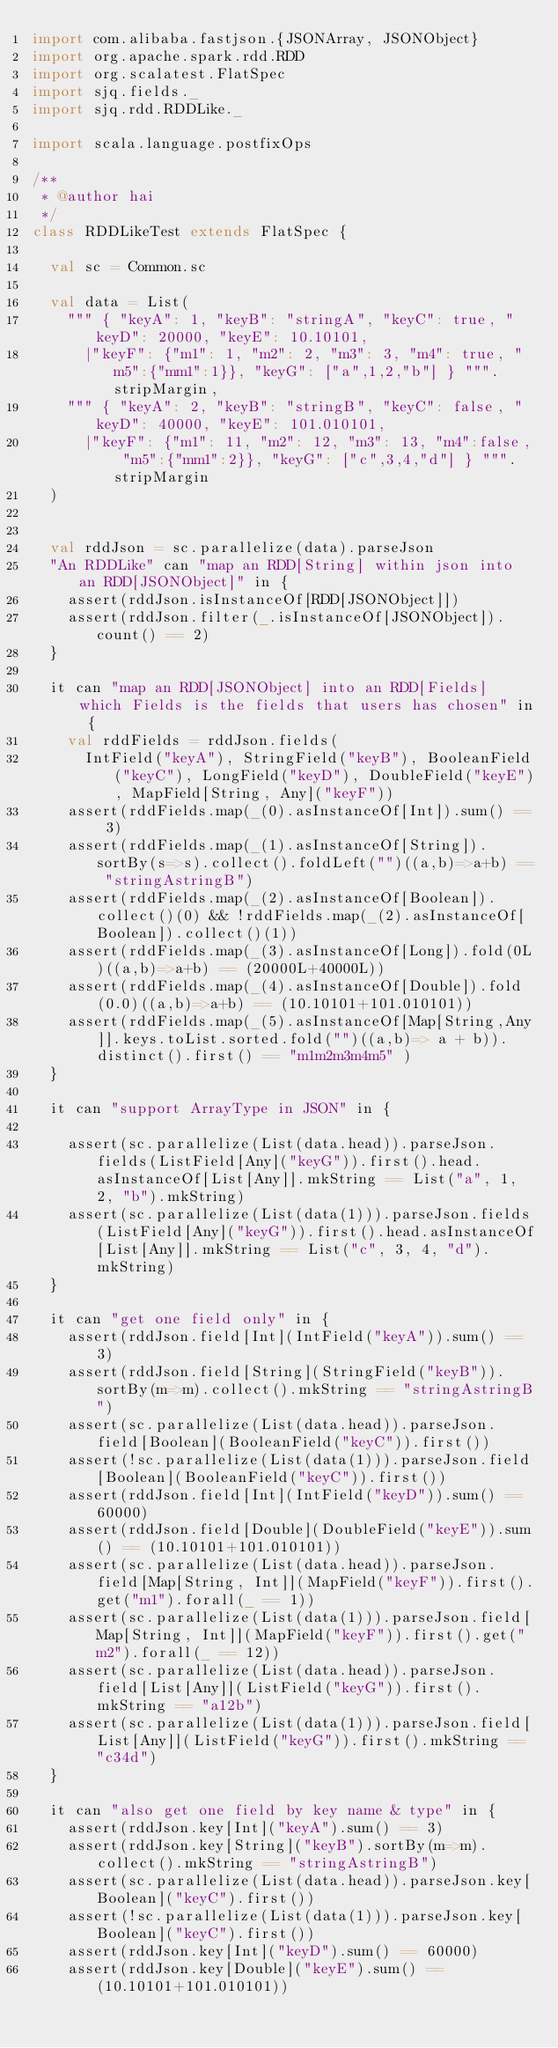Convert code to text. <code><loc_0><loc_0><loc_500><loc_500><_Scala_>import com.alibaba.fastjson.{JSONArray, JSONObject}
import org.apache.spark.rdd.RDD
import org.scalatest.FlatSpec
import sjq.fields._
import sjq.rdd.RDDLike._

import scala.language.postfixOps

/**
 * @author hai
 */
class RDDLikeTest extends FlatSpec {

  val sc = Common.sc

  val data = List(
    """ { "keyA": 1, "keyB": "stringA", "keyC": true, "keyD": 20000, "keyE": 10.10101,
      |"keyF": {"m1": 1, "m2": 2, "m3": 3, "m4": true, "m5":{"mm1":1}}, "keyG": ["a",1,2,"b"] } """.stripMargin,
    """ { "keyA": 2, "keyB": "stringB", "keyC": false, "keyD": 40000, "keyE": 101.010101,
      |"keyF": {"m1": 11, "m2": 12, "m3": 13, "m4":false, "m5":{"mm1":2}}, "keyG": ["c",3,4,"d"] } """.stripMargin
  )


  val rddJson = sc.parallelize(data).parseJson
  "An RDDLike" can "map an RDD[String] within json into an RDD[JSONObject]" in {
    assert(rddJson.isInstanceOf[RDD[JSONObject]])
    assert(rddJson.filter(_.isInstanceOf[JSONObject]).count() == 2)
  }

  it can "map an RDD[JSONObject] into an RDD[Fields] which Fields is the fields that users has chosen" in {
    val rddFields = rddJson.fields(
      IntField("keyA"), StringField("keyB"), BooleanField("keyC"), LongField("keyD"), DoubleField("keyE"), MapField[String, Any]("keyF"))
    assert(rddFields.map(_(0).asInstanceOf[Int]).sum() == 3)
    assert(rddFields.map(_(1).asInstanceOf[String]).sortBy(s=>s).collect().foldLeft("")((a,b)=>a+b) == "stringAstringB")
    assert(rddFields.map(_(2).asInstanceOf[Boolean]).collect()(0) && !rddFields.map(_(2).asInstanceOf[Boolean]).collect()(1))
    assert(rddFields.map(_(3).asInstanceOf[Long]).fold(0L)((a,b)=>a+b) == (20000L+40000L))
    assert(rddFields.map(_(4).asInstanceOf[Double]).fold(0.0)((a,b)=>a+b) == (10.10101+101.010101))
    assert(rddFields.map(_(5).asInstanceOf[Map[String,Any]].keys.toList.sorted.fold("")((a,b)=> a + b)).distinct().first() == "m1m2m3m4m5" )
  }

  it can "support ArrayType in JSON" in {

    assert(sc.parallelize(List(data.head)).parseJson.fields(ListField[Any]("keyG")).first().head.asInstanceOf[List[Any]].mkString == List("a", 1, 2, "b").mkString)
    assert(sc.parallelize(List(data(1))).parseJson.fields(ListField[Any]("keyG")).first().head.asInstanceOf[List[Any]].mkString == List("c", 3, 4, "d").mkString)
  }

  it can "get one field only" in {
    assert(rddJson.field[Int](IntField("keyA")).sum() == 3)
    assert(rddJson.field[String](StringField("keyB")).sortBy(m=>m).collect().mkString == "stringAstringB")
    assert(sc.parallelize(List(data.head)).parseJson.field[Boolean](BooleanField("keyC")).first())
    assert(!sc.parallelize(List(data(1))).parseJson.field[Boolean](BooleanField("keyC")).first())
    assert(rddJson.field[Int](IntField("keyD")).sum() == 60000)
    assert(rddJson.field[Double](DoubleField("keyE")).sum() == (10.10101+101.010101))
    assert(sc.parallelize(List(data.head)).parseJson.field[Map[String, Int]](MapField("keyF")).first().get("m1").forall(_ == 1))
    assert(sc.parallelize(List(data(1))).parseJson.field[Map[String, Int]](MapField("keyF")).first().get("m2").forall(_ == 12))
    assert(sc.parallelize(List(data.head)).parseJson.field[List[Any]](ListField("keyG")).first().mkString == "a12b")
    assert(sc.parallelize(List(data(1))).parseJson.field[List[Any]](ListField("keyG")).first().mkString == "c34d")
  }

  it can "also get one field by key name & type" in {
    assert(rddJson.key[Int]("keyA").sum() == 3)
    assert(rddJson.key[String]("keyB").sortBy(m=>m).collect().mkString == "stringAstringB")
    assert(sc.parallelize(List(data.head)).parseJson.key[Boolean]("keyC").first())
    assert(!sc.parallelize(List(data(1))).parseJson.key[Boolean]("keyC").first())
    assert(rddJson.key[Int]("keyD").sum() == 60000)
    assert(rddJson.key[Double]("keyE").sum() == (10.10101+101.010101))</code> 